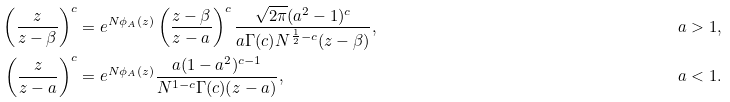<formula> <loc_0><loc_0><loc_500><loc_500>\left ( \frac { z } { z - \beta } \right ) ^ { c } & = e ^ { N \phi _ { A } ( z ) } \left ( \frac { z - \beta } { z - a } \right ) ^ { c } \frac { \sqrt { 2 \pi } ( a ^ { 2 } - 1 ) ^ { c } } { a \Gamma ( c ) N ^ { \frac { 1 } { 2 } - c } ( z - \beta ) } , & a > 1 , \\ \left ( \frac { z } { z - a } \right ) ^ { c } & = e ^ { N \phi _ { A } ( z ) } \frac { a ( 1 - a ^ { 2 } ) ^ { c - 1 } } { N ^ { 1 - c } \Gamma ( c ) ( z - a ) } , & a < 1 .</formula> 